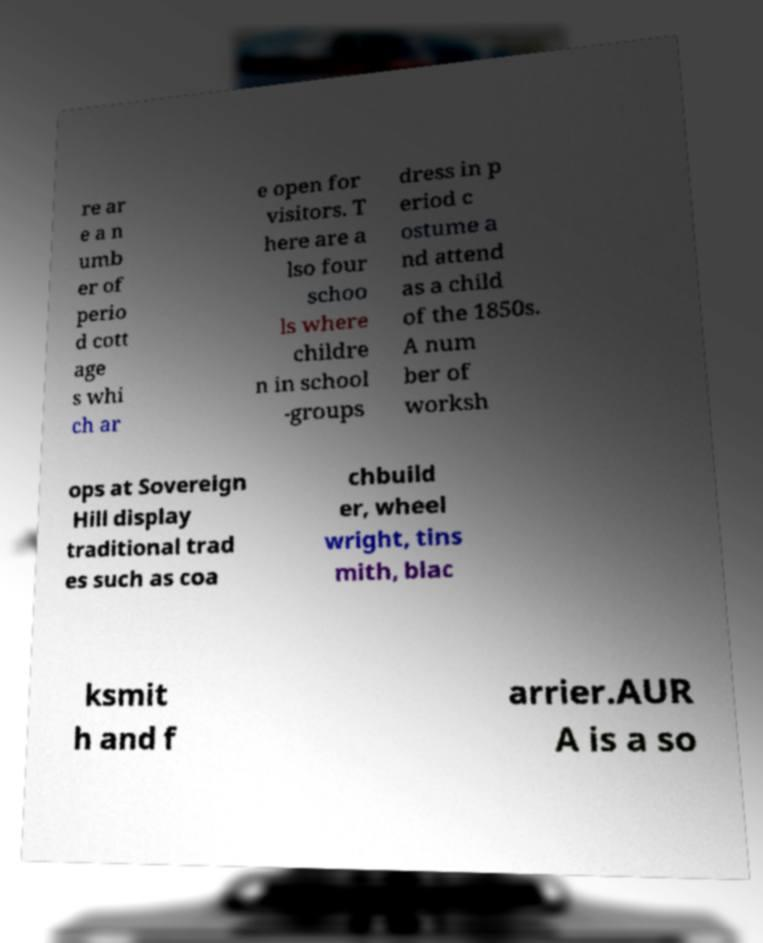Please identify and transcribe the text found in this image. re ar e a n umb er of perio d cott age s whi ch ar e open for visitors. T here are a lso four schoo ls where childre n in school -groups dress in p eriod c ostume a nd attend as a child of the 1850s. A num ber of worksh ops at Sovereign Hill display traditional trad es such as coa chbuild er, wheel wright, tins mith, blac ksmit h and f arrier.AUR A is a so 